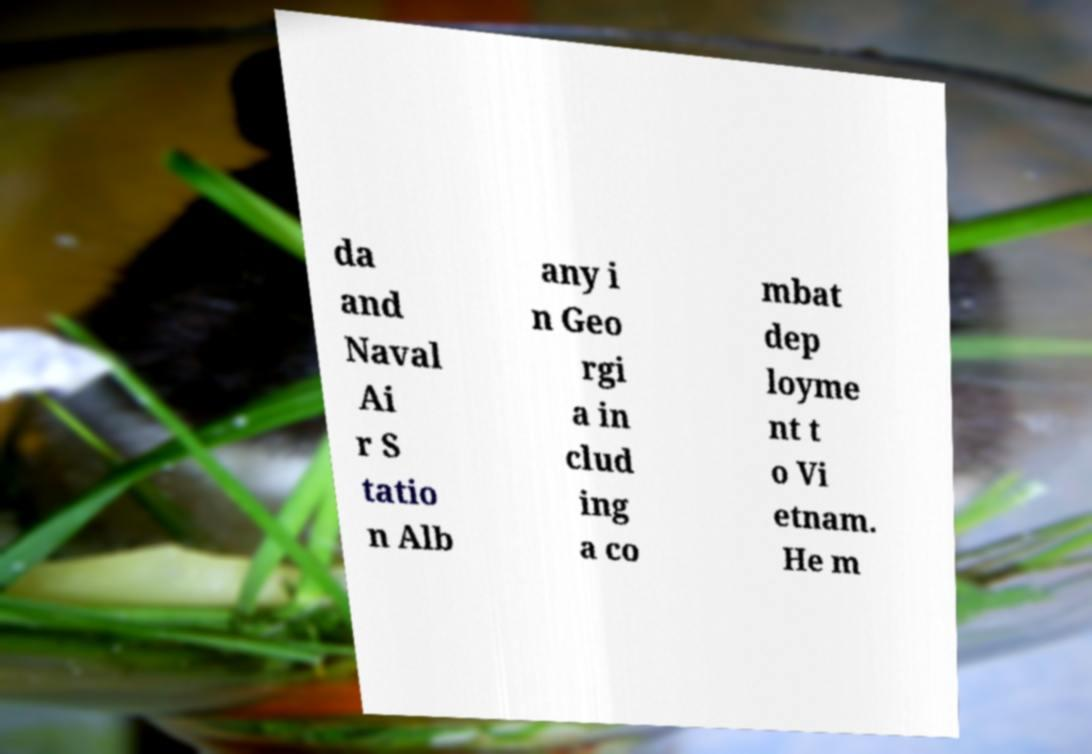Please read and relay the text visible in this image. What does it say? da and Naval Ai r S tatio n Alb any i n Geo rgi a in clud ing a co mbat dep loyme nt t o Vi etnam. He m 